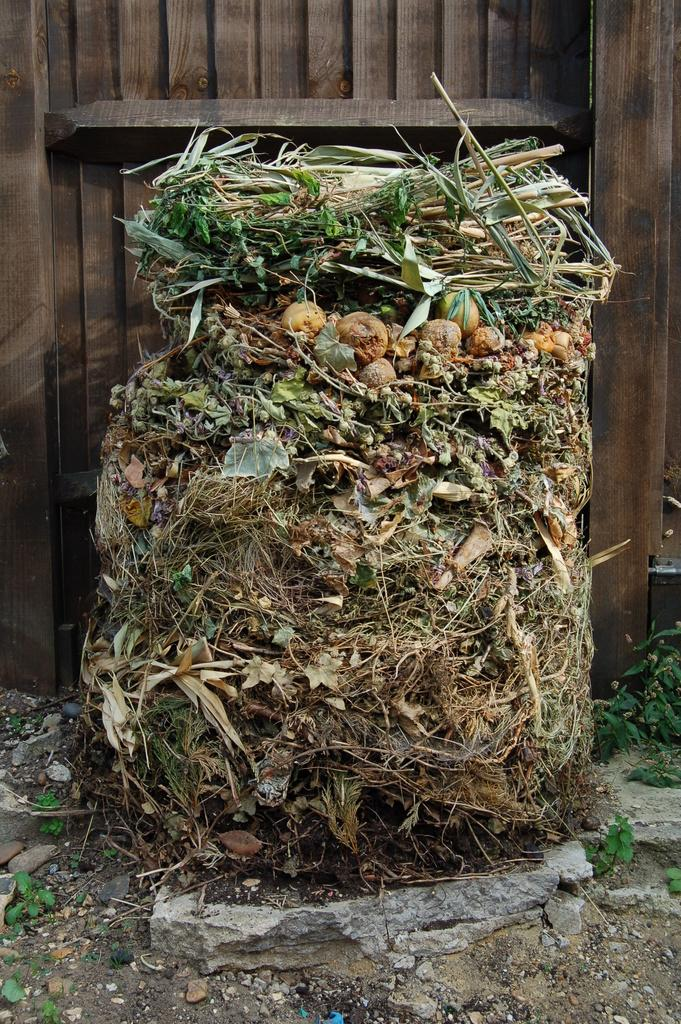What type of waste is present in the image? There is garbage in the image. What type of food items can be seen in the image? There are fruits in the image. What type of vegetation is present in the image? There is grass in the image, which resembles hay. What type of door is present in the image? There is a wooden door in the image. Can you see any smoke coming from the garbage in the image? There is no smoke present in the image; it only shows garbage, fruits, grass, and a wooden door. Is there any wind blowing in the image? There is no indication of wind in the image, as it only shows static objects like garbage, fruits, grass, and a wooden door. 